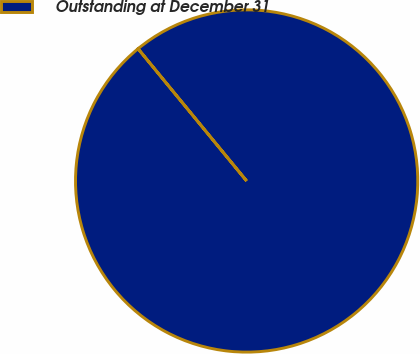Convert chart. <chart><loc_0><loc_0><loc_500><loc_500><pie_chart><fcel>Outstanding at December 31<nl><fcel>100.0%<nl></chart> 